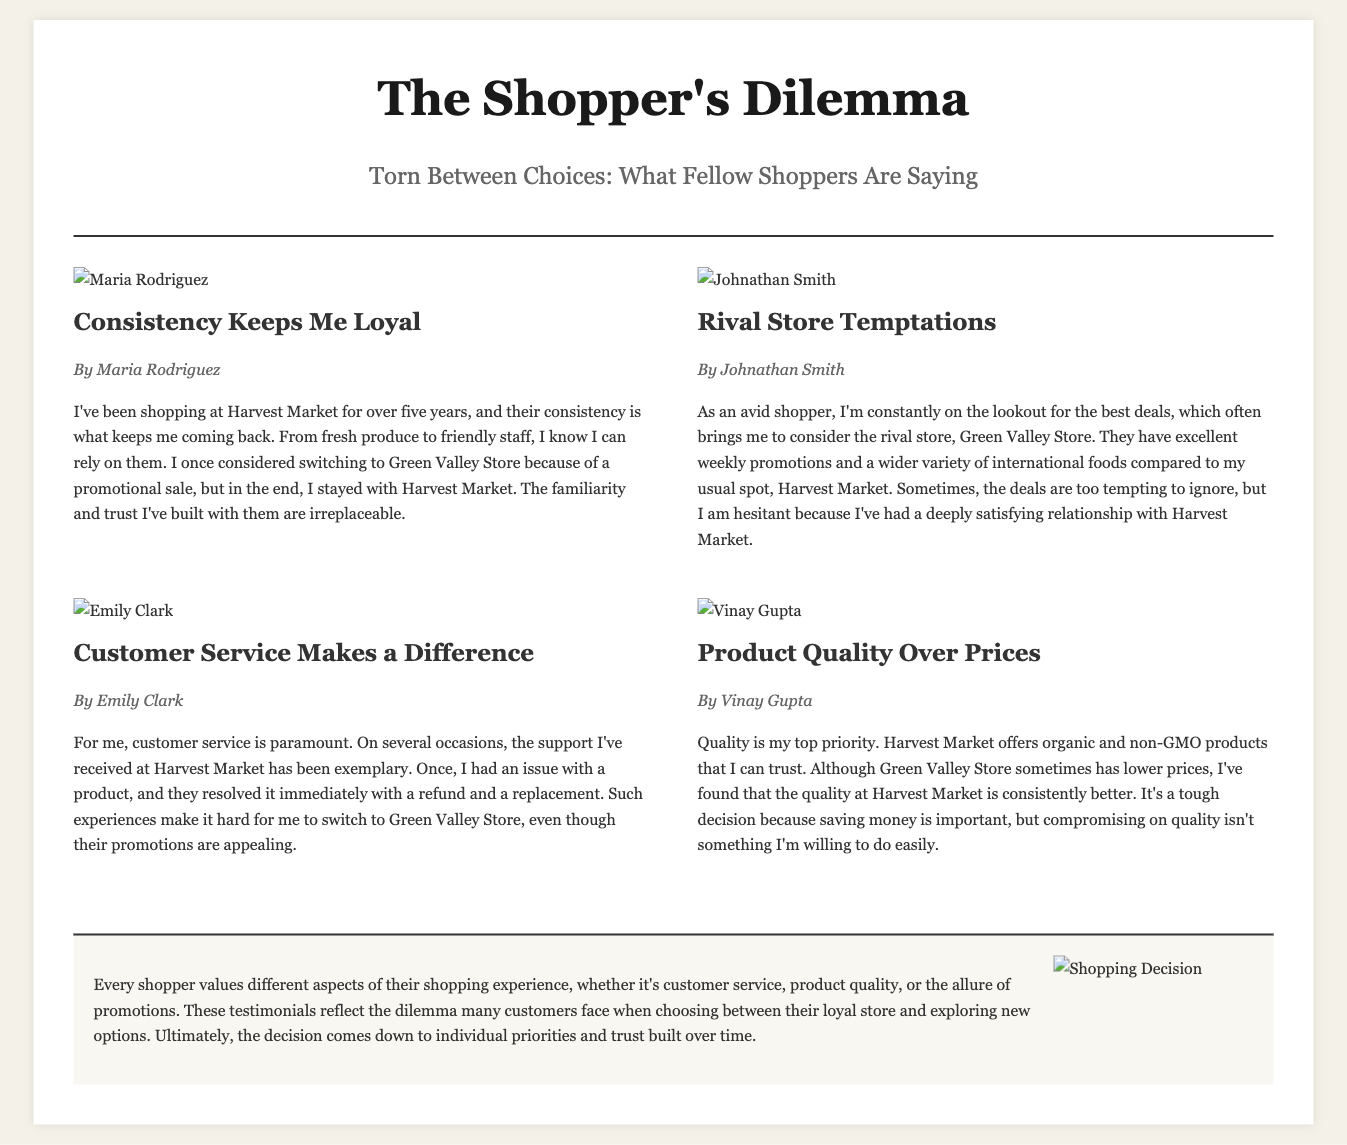What is the title of the newspaper? The title is the main headline that identifies the publication, which is "The Shopper's Dilemma."
Answer: The Shopper's Dilemma Who wrote the testimonial about customer service? The testimonial specifically discussing customer service is authored by Emily Clark.
Answer: Emily Clark How many testimonials are included in the document? The document features a total of four testimonials from different shoppers.
Answer: Four What is the main reason Maria Rodriguez remains loyal to Harvest Market? Maria emphasizes consistency in product quality and staff friendliness as her reasons for loyalty.
Answer: Consistency Which store does Johnathan Smith consider switching to? Johnathan mentions considering switching to a rival store due to their promotions.
Answer: Green Valley Store What product quality attribute does Vinay Gupta prioritize? Vinay focuses on organic and non-GMO products as his priority for quality.
Answer: Organic and non-GMO What type of product issue did Emily Clark encounter at Harvest Market? Emily Clark experienced an issue with a product for which she sought support.
Answer: Product issue What does the conclusion suggest is a common feeling among shoppers? The conclusion implies that customers often face a dilemma between loyalty and exploring new options.
Answer: Dilemma 